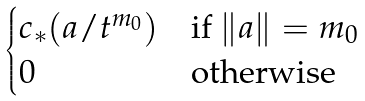<formula> <loc_0><loc_0><loc_500><loc_500>\begin{cases} c _ { * } ( a / t ^ { m _ { 0 } } ) & \text {if $\|a \| = m_{0}$} \\ 0 & \text {otherwise} \end{cases}</formula> 